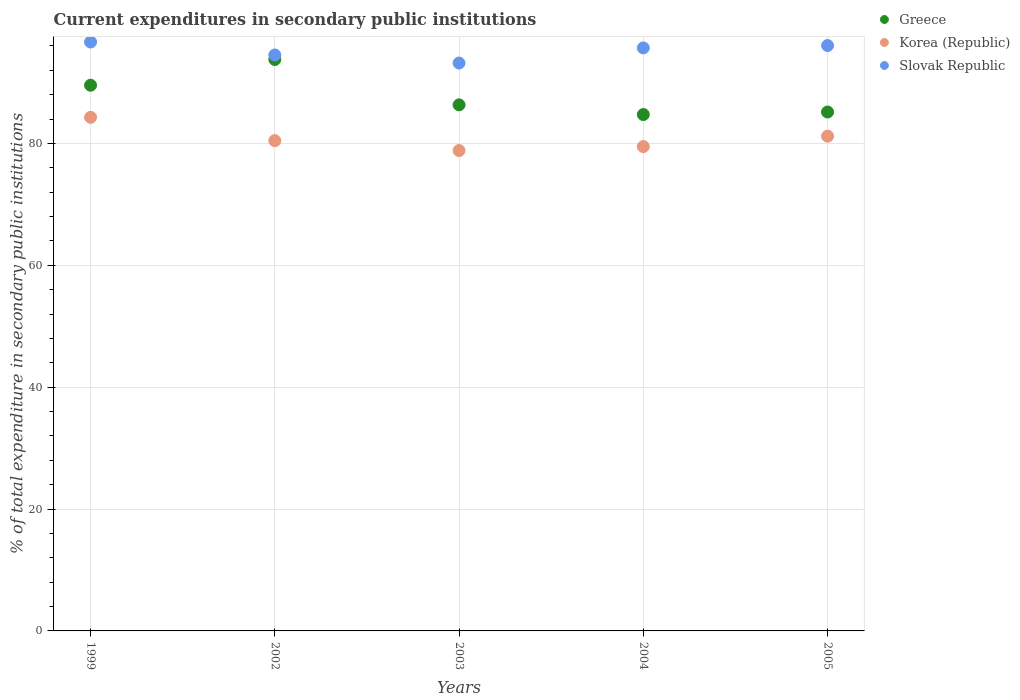What is the current expenditures in secondary public institutions in Korea (Republic) in 2003?
Keep it short and to the point. 78.83. Across all years, what is the maximum current expenditures in secondary public institutions in Korea (Republic)?
Ensure brevity in your answer.  84.29. Across all years, what is the minimum current expenditures in secondary public institutions in Slovak Republic?
Your answer should be very brief. 93.19. In which year was the current expenditures in secondary public institutions in Slovak Republic minimum?
Your answer should be very brief. 2003. What is the total current expenditures in secondary public institutions in Greece in the graph?
Your answer should be very brief. 439.56. What is the difference between the current expenditures in secondary public institutions in Korea (Republic) in 1999 and that in 2005?
Ensure brevity in your answer.  3.1. What is the difference between the current expenditures in secondary public institutions in Greece in 2002 and the current expenditures in secondary public institutions in Korea (Republic) in 2003?
Provide a succinct answer. 14.94. What is the average current expenditures in secondary public institutions in Korea (Republic) per year?
Give a very brief answer. 80.85. In the year 1999, what is the difference between the current expenditures in secondary public institutions in Korea (Republic) and current expenditures in secondary public institutions in Greece?
Offer a terse response. -5.27. What is the ratio of the current expenditures in secondary public institutions in Korea (Republic) in 2003 to that in 2004?
Ensure brevity in your answer.  0.99. Is the difference between the current expenditures in secondary public institutions in Korea (Republic) in 2004 and 2005 greater than the difference between the current expenditures in secondary public institutions in Greece in 2004 and 2005?
Make the answer very short. No. What is the difference between the highest and the second highest current expenditures in secondary public institutions in Greece?
Your answer should be very brief. 4.22. What is the difference between the highest and the lowest current expenditures in secondary public institutions in Greece?
Make the answer very short. 9.03. Is the sum of the current expenditures in secondary public institutions in Greece in 2002 and 2003 greater than the maximum current expenditures in secondary public institutions in Slovak Republic across all years?
Ensure brevity in your answer.  Yes. Where does the legend appear in the graph?
Your answer should be compact. Top right. How many legend labels are there?
Your response must be concise. 3. How are the legend labels stacked?
Provide a short and direct response. Vertical. What is the title of the graph?
Give a very brief answer. Current expenditures in secondary public institutions. What is the label or title of the X-axis?
Ensure brevity in your answer.  Years. What is the label or title of the Y-axis?
Ensure brevity in your answer.  % of total expenditure in secondary public institutions. What is the % of total expenditure in secondary public institutions in Greece in 1999?
Provide a short and direct response. 89.55. What is the % of total expenditure in secondary public institutions of Korea (Republic) in 1999?
Your response must be concise. 84.29. What is the % of total expenditure in secondary public institutions of Slovak Republic in 1999?
Give a very brief answer. 96.65. What is the % of total expenditure in secondary public institutions of Greece in 2002?
Provide a short and direct response. 93.77. What is the % of total expenditure in secondary public institutions in Korea (Republic) in 2002?
Ensure brevity in your answer.  80.46. What is the % of total expenditure in secondary public institutions in Slovak Republic in 2002?
Your answer should be very brief. 94.52. What is the % of total expenditure in secondary public institutions of Greece in 2003?
Your answer should be compact. 86.33. What is the % of total expenditure in secondary public institutions of Korea (Republic) in 2003?
Your answer should be compact. 78.83. What is the % of total expenditure in secondary public institutions in Slovak Republic in 2003?
Provide a succinct answer. 93.19. What is the % of total expenditure in secondary public institutions of Greece in 2004?
Provide a short and direct response. 84.74. What is the % of total expenditure in secondary public institutions of Korea (Republic) in 2004?
Keep it short and to the point. 79.48. What is the % of total expenditure in secondary public institutions in Slovak Republic in 2004?
Offer a very short reply. 95.68. What is the % of total expenditure in secondary public institutions of Greece in 2005?
Provide a short and direct response. 85.16. What is the % of total expenditure in secondary public institutions of Korea (Republic) in 2005?
Provide a succinct answer. 81.19. What is the % of total expenditure in secondary public institutions in Slovak Republic in 2005?
Offer a very short reply. 96.07. Across all years, what is the maximum % of total expenditure in secondary public institutions in Greece?
Offer a terse response. 93.77. Across all years, what is the maximum % of total expenditure in secondary public institutions in Korea (Republic)?
Provide a succinct answer. 84.29. Across all years, what is the maximum % of total expenditure in secondary public institutions in Slovak Republic?
Ensure brevity in your answer.  96.65. Across all years, what is the minimum % of total expenditure in secondary public institutions in Greece?
Your answer should be compact. 84.74. Across all years, what is the minimum % of total expenditure in secondary public institutions of Korea (Republic)?
Give a very brief answer. 78.83. Across all years, what is the minimum % of total expenditure in secondary public institutions in Slovak Republic?
Give a very brief answer. 93.19. What is the total % of total expenditure in secondary public institutions in Greece in the graph?
Give a very brief answer. 439.56. What is the total % of total expenditure in secondary public institutions in Korea (Republic) in the graph?
Ensure brevity in your answer.  404.25. What is the total % of total expenditure in secondary public institutions of Slovak Republic in the graph?
Give a very brief answer. 476.11. What is the difference between the % of total expenditure in secondary public institutions of Greece in 1999 and that in 2002?
Your response must be concise. -4.22. What is the difference between the % of total expenditure in secondary public institutions of Korea (Republic) in 1999 and that in 2002?
Keep it short and to the point. 3.83. What is the difference between the % of total expenditure in secondary public institutions in Slovak Republic in 1999 and that in 2002?
Ensure brevity in your answer.  2.12. What is the difference between the % of total expenditure in secondary public institutions in Greece in 1999 and that in 2003?
Offer a terse response. 3.22. What is the difference between the % of total expenditure in secondary public institutions in Korea (Republic) in 1999 and that in 2003?
Keep it short and to the point. 5.45. What is the difference between the % of total expenditure in secondary public institutions of Slovak Republic in 1999 and that in 2003?
Your answer should be compact. 3.45. What is the difference between the % of total expenditure in secondary public institutions of Greece in 1999 and that in 2004?
Your answer should be compact. 4.81. What is the difference between the % of total expenditure in secondary public institutions in Korea (Republic) in 1999 and that in 2004?
Provide a short and direct response. 4.8. What is the difference between the % of total expenditure in secondary public institutions in Slovak Republic in 1999 and that in 2004?
Offer a terse response. 0.97. What is the difference between the % of total expenditure in secondary public institutions in Greece in 1999 and that in 2005?
Provide a short and direct response. 4.4. What is the difference between the % of total expenditure in secondary public institutions of Korea (Republic) in 1999 and that in 2005?
Keep it short and to the point. 3.1. What is the difference between the % of total expenditure in secondary public institutions in Slovak Republic in 1999 and that in 2005?
Make the answer very short. 0.58. What is the difference between the % of total expenditure in secondary public institutions of Greece in 2002 and that in 2003?
Your answer should be compact. 7.44. What is the difference between the % of total expenditure in secondary public institutions of Korea (Republic) in 2002 and that in 2003?
Provide a succinct answer. 1.62. What is the difference between the % of total expenditure in secondary public institutions in Slovak Republic in 2002 and that in 2003?
Ensure brevity in your answer.  1.33. What is the difference between the % of total expenditure in secondary public institutions in Greece in 2002 and that in 2004?
Make the answer very short. 9.03. What is the difference between the % of total expenditure in secondary public institutions of Korea (Republic) in 2002 and that in 2004?
Ensure brevity in your answer.  0.97. What is the difference between the % of total expenditure in secondary public institutions in Slovak Republic in 2002 and that in 2004?
Offer a terse response. -1.16. What is the difference between the % of total expenditure in secondary public institutions in Greece in 2002 and that in 2005?
Offer a terse response. 8.62. What is the difference between the % of total expenditure in secondary public institutions in Korea (Republic) in 2002 and that in 2005?
Provide a succinct answer. -0.73. What is the difference between the % of total expenditure in secondary public institutions in Slovak Republic in 2002 and that in 2005?
Your answer should be compact. -1.54. What is the difference between the % of total expenditure in secondary public institutions of Greece in 2003 and that in 2004?
Make the answer very short. 1.59. What is the difference between the % of total expenditure in secondary public institutions in Korea (Republic) in 2003 and that in 2004?
Offer a very short reply. -0.65. What is the difference between the % of total expenditure in secondary public institutions of Slovak Republic in 2003 and that in 2004?
Offer a very short reply. -2.48. What is the difference between the % of total expenditure in secondary public institutions in Greece in 2003 and that in 2005?
Make the answer very short. 1.18. What is the difference between the % of total expenditure in secondary public institutions in Korea (Republic) in 2003 and that in 2005?
Your answer should be compact. -2.36. What is the difference between the % of total expenditure in secondary public institutions of Slovak Republic in 2003 and that in 2005?
Keep it short and to the point. -2.87. What is the difference between the % of total expenditure in secondary public institutions of Greece in 2004 and that in 2005?
Provide a short and direct response. -0.41. What is the difference between the % of total expenditure in secondary public institutions in Korea (Republic) in 2004 and that in 2005?
Provide a short and direct response. -1.71. What is the difference between the % of total expenditure in secondary public institutions of Slovak Republic in 2004 and that in 2005?
Your response must be concise. -0.39. What is the difference between the % of total expenditure in secondary public institutions in Greece in 1999 and the % of total expenditure in secondary public institutions in Korea (Republic) in 2002?
Give a very brief answer. 9.1. What is the difference between the % of total expenditure in secondary public institutions of Greece in 1999 and the % of total expenditure in secondary public institutions of Slovak Republic in 2002?
Your answer should be compact. -4.97. What is the difference between the % of total expenditure in secondary public institutions of Korea (Republic) in 1999 and the % of total expenditure in secondary public institutions of Slovak Republic in 2002?
Provide a short and direct response. -10.23. What is the difference between the % of total expenditure in secondary public institutions in Greece in 1999 and the % of total expenditure in secondary public institutions in Korea (Republic) in 2003?
Make the answer very short. 10.72. What is the difference between the % of total expenditure in secondary public institutions of Greece in 1999 and the % of total expenditure in secondary public institutions of Slovak Republic in 2003?
Make the answer very short. -3.64. What is the difference between the % of total expenditure in secondary public institutions of Korea (Republic) in 1999 and the % of total expenditure in secondary public institutions of Slovak Republic in 2003?
Your answer should be very brief. -8.91. What is the difference between the % of total expenditure in secondary public institutions in Greece in 1999 and the % of total expenditure in secondary public institutions in Korea (Republic) in 2004?
Ensure brevity in your answer.  10.07. What is the difference between the % of total expenditure in secondary public institutions of Greece in 1999 and the % of total expenditure in secondary public institutions of Slovak Republic in 2004?
Offer a very short reply. -6.13. What is the difference between the % of total expenditure in secondary public institutions in Korea (Republic) in 1999 and the % of total expenditure in secondary public institutions in Slovak Republic in 2004?
Offer a very short reply. -11.39. What is the difference between the % of total expenditure in secondary public institutions of Greece in 1999 and the % of total expenditure in secondary public institutions of Korea (Republic) in 2005?
Offer a very short reply. 8.36. What is the difference between the % of total expenditure in secondary public institutions in Greece in 1999 and the % of total expenditure in secondary public institutions in Slovak Republic in 2005?
Keep it short and to the point. -6.51. What is the difference between the % of total expenditure in secondary public institutions of Korea (Republic) in 1999 and the % of total expenditure in secondary public institutions of Slovak Republic in 2005?
Provide a succinct answer. -11.78. What is the difference between the % of total expenditure in secondary public institutions of Greece in 2002 and the % of total expenditure in secondary public institutions of Korea (Republic) in 2003?
Ensure brevity in your answer.  14.94. What is the difference between the % of total expenditure in secondary public institutions in Greece in 2002 and the % of total expenditure in secondary public institutions in Slovak Republic in 2003?
Your response must be concise. 0.58. What is the difference between the % of total expenditure in secondary public institutions of Korea (Republic) in 2002 and the % of total expenditure in secondary public institutions of Slovak Republic in 2003?
Give a very brief answer. -12.74. What is the difference between the % of total expenditure in secondary public institutions of Greece in 2002 and the % of total expenditure in secondary public institutions of Korea (Republic) in 2004?
Make the answer very short. 14.29. What is the difference between the % of total expenditure in secondary public institutions of Greece in 2002 and the % of total expenditure in secondary public institutions of Slovak Republic in 2004?
Your response must be concise. -1.9. What is the difference between the % of total expenditure in secondary public institutions of Korea (Republic) in 2002 and the % of total expenditure in secondary public institutions of Slovak Republic in 2004?
Provide a succinct answer. -15.22. What is the difference between the % of total expenditure in secondary public institutions of Greece in 2002 and the % of total expenditure in secondary public institutions of Korea (Republic) in 2005?
Give a very brief answer. 12.58. What is the difference between the % of total expenditure in secondary public institutions in Greece in 2002 and the % of total expenditure in secondary public institutions in Slovak Republic in 2005?
Make the answer very short. -2.29. What is the difference between the % of total expenditure in secondary public institutions of Korea (Republic) in 2002 and the % of total expenditure in secondary public institutions of Slovak Republic in 2005?
Provide a succinct answer. -15.61. What is the difference between the % of total expenditure in secondary public institutions of Greece in 2003 and the % of total expenditure in secondary public institutions of Korea (Republic) in 2004?
Keep it short and to the point. 6.85. What is the difference between the % of total expenditure in secondary public institutions in Greece in 2003 and the % of total expenditure in secondary public institutions in Slovak Republic in 2004?
Give a very brief answer. -9.35. What is the difference between the % of total expenditure in secondary public institutions in Korea (Republic) in 2003 and the % of total expenditure in secondary public institutions in Slovak Republic in 2004?
Offer a very short reply. -16.84. What is the difference between the % of total expenditure in secondary public institutions of Greece in 2003 and the % of total expenditure in secondary public institutions of Korea (Republic) in 2005?
Make the answer very short. 5.14. What is the difference between the % of total expenditure in secondary public institutions in Greece in 2003 and the % of total expenditure in secondary public institutions in Slovak Republic in 2005?
Offer a terse response. -9.73. What is the difference between the % of total expenditure in secondary public institutions of Korea (Republic) in 2003 and the % of total expenditure in secondary public institutions of Slovak Republic in 2005?
Make the answer very short. -17.23. What is the difference between the % of total expenditure in secondary public institutions of Greece in 2004 and the % of total expenditure in secondary public institutions of Korea (Republic) in 2005?
Give a very brief answer. 3.55. What is the difference between the % of total expenditure in secondary public institutions of Greece in 2004 and the % of total expenditure in secondary public institutions of Slovak Republic in 2005?
Offer a very short reply. -11.32. What is the difference between the % of total expenditure in secondary public institutions of Korea (Republic) in 2004 and the % of total expenditure in secondary public institutions of Slovak Republic in 2005?
Provide a succinct answer. -16.58. What is the average % of total expenditure in secondary public institutions of Greece per year?
Offer a very short reply. 87.91. What is the average % of total expenditure in secondary public institutions in Korea (Republic) per year?
Keep it short and to the point. 80.85. What is the average % of total expenditure in secondary public institutions in Slovak Republic per year?
Provide a succinct answer. 95.22. In the year 1999, what is the difference between the % of total expenditure in secondary public institutions in Greece and % of total expenditure in secondary public institutions in Korea (Republic)?
Keep it short and to the point. 5.27. In the year 1999, what is the difference between the % of total expenditure in secondary public institutions of Greece and % of total expenditure in secondary public institutions of Slovak Republic?
Provide a succinct answer. -7.09. In the year 1999, what is the difference between the % of total expenditure in secondary public institutions in Korea (Republic) and % of total expenditure in secondary public institutions in Slovak Republic?
Your answer should be very brief. -12.36. In the year 2002, what is the difference between the % of total expenditure in secondary public institutions in Greece and % of total expenditure in secondary public institutions in Korea (Republic)?
Make the answer very short. 13.32. In the year 2002, what is the difference between the % of total expenditure in secondary public institutions in Greece and % of total expenditure in secondary public institutions in Slovak Republic?
Ensure brevity in your answer.  -0.75. In the year 2002, what is the difference between the % of total expenditure in secondary public institutions of Korea (Republic) and % of total expenditure in secondary public institutions of Slovak Republic?
Offer a terse response. -14.06. In the year 2003, what is the difference between the % of total expenditure in secondary public institutions of Greece and % of total expenditure in secondary public institutions of Korea (Republic)?
Keep it short and to the point. 7.5. In the year 2003, what is the difference between the % of total expenditure in secondary public institutions of Greece and % of total expenditure in secondary public institutions of Slovak Republic?
Make the answer very short. -6.86. In the year 2003, what is the difference between the % of total expenditure in secondary public institutions in Korea (Republic) and % of total expenditure in secondary public institutions in Slovak Republic?
Your answer should be compact. -14.36. In the year 2004, what is the difference between the % of total expenditure in secondary public institutions of Greece and % of total expenditure in secondary public institutions of Korea (Republic)?
Give a very brief answer. 5.26. In the year 2004, what is the difference between the % of total expenditure in secondary public institutions in Greece and % of total expenditure in secondary public institutions in Slovak Republic?
Keep it short and to the point. -10.94. In the year 2004, what is the difference between the % of total expenditure in secondary public institutions in Korea (Republic) and % of total expenditure in secondary public institutions in Slovak Republic?
Offer a very short reply. -16.19. In the year 2005, what is the difference between the % of total expenditure in secondary public institutions of Greece and % of total expenditure in secondary public institutions of Korea (Republic)?
Provide a short and direct response. 3.97. In the year 2005, what is the difference between the % of total expenditure in secondary public institutions in Greece and % of total expenditure in secondary public institutions in Slovak Republic?
Ensure brevity in your answer.  -10.91. In the year 2005, what is the difference between the % of total expenditure in secondary public institutions of Korea (Republic) and % of total expenditure in secondary public institutions of Slovak Republic?
Provide a short and direct response. -14.87. What is the ratio of the % of total expenditure in secondary public institutions of Greece in 1999 to that in 2002?
Your answer should be compact. 0.95. What is the ratio of the % of total expenditure in secondary public institutions in Korea (Republic) in 1999 to that in 2002?
Make the answer very short. 1.05. What is the ratio of the % of total expenditure in secondary public institutions in Slovak Republic in 1999 to that in 2002?
Provide a short and direct response. 1.02. What is the ratio of the % of total expenditure in secondary public institutions of Greece in 1999 to that in 2003?
Offer a terse response. 1.04. What is the ratio of the % of total expenditure in secondary public institutions in Korea (Republic) in 1999 to that in 2003?
Provide a succinct answer. 1.07. What is the ratio of the % of total expenditure in secondary public institutions in Greece in 1999 to that in 2004?
Your answer should be very brief. 1.06. What is the ratio of the % of total expenditure in secondary public institutions of Korea (Republic) in 1999 to that in 2004?
Provide a succinct answer. 1.06. What is the ratio of the % of total expenditure in secondary public institutions of Slovak Republic in 1999 to that in 2004?
Keep it short and to the point. 1.01. What is the ratio of the % of total expenditure in secondary public institutions of Greece in 1999 to that in 2005?
Provide a succinct answer. 1.05. What is the ratio of the % of total expenditure in secondary public institutions of Korea (Republic) in 1999 to that in 2005?
Your answer should be very brief. 1.04. What is the ratio of the % of total expenditure in secondary public institutions in Greece in 2002 to that in 2003?
Make the answer very short. 1.09. What is the ratio of the % of total expenditure in secondary public institutions in Korea (Republic) in 2002 to that in 2003?
Your answer should be very brief. 1.02. What is the ratio of the % of total expenditure in secondary public institutions of Slovak Republic in 2002 to that in 2003?
Provide a short and direct response. 1.01. What is the ratio of the % of total expenditure in secondary public institutions in Greece in 2002 to that in 2004?
Provide a succinct answer. 1.11. What is the ratio of the % of total expenditure in secondary public institutions in Korea (Republic) in 2002 to that in 2004?
Provide a short and direct response. 1.01. What is the ratio of the % of total expenditure in secondary public institutions of Slovak Republic in 2002 to that in 2004?
Your answer should be compact. 0.99. What is the ratio of the % of total expenditure in secondary public institutions in Greece in 2002 to that in 2005?
Provide a succinct answer. 1.1. What is the ratio of the % of total expenditure in secondary public institutions in Slovak Republic in 2002 to that in 2005?
Your answer should be compact. 0.98. What is the ratio of the % of total expenditure in secondary public institutions in Greece in 2003 to that in 2004?
Provide a succinct answer. 1.02. What is the ratio of the % of total expenditure in secondary public institutions of Slovak Republic in 2003 to that in 2004?
Make the answer very short. 0.97. What is the ratio of the % of total expenditure in secondary public institutions in Greece in 2003 to that in 2005?
Keep it short and to the point. 1.01. What is the ratio of the % of total expenditure in secondary public institutions in Korea (Republic) in 2003 to that in 2005?
Your answer should be compact. 0.97. What is the ratio of the % of total expenditure in secondary public institutions in Slovak Republic in 2003 to that in 2005?
Ensure brevity in your answer.  0.97. What is the ratio of the % of total expenditure in secondary public institutions of Greece in 2004 to that in 2005?
Keep it short and to the point. 1. What is the ratio of the % of total expenditure in secondary public institutions in Korea (Republic) in 2004 to that in 2005?
Your answer should be compact. 0.98. What is the ratio of the % of total expenditure in secondary public institutions in Slovak Republic in 2004 to that in 2005?
Provide a short and direct response. 1. What is the difference between the highest and the second highest % of total expenditure in secondary public institutions of Greece?
Provide a short and direct response. 4.22. What is the difference between the highest and the second highest % of total expenditure in secondary public institutions in Korea (Republic)?
Your answer should be very brief. 3.1. What is the difference between the highest and the second highest % of total expenditure in secondary public institutions of Slovak Republic?
Your answer should be very brief. 0.58. What is the difference between the highest and the lowest % of total expenditure in secondary public institutions of Greece?
Keep it short and to the point. 9.03. What is the difference between the highest and the lowest % of total expenditure in secondary public institutions in Korea (Republic)?
Provide a short and direct response. 5.45. What is the difference between the highest and the lowest % of total expenditure in secondary public institutions in Slovak Republic?
Your answer should be very brief. 3.45. 